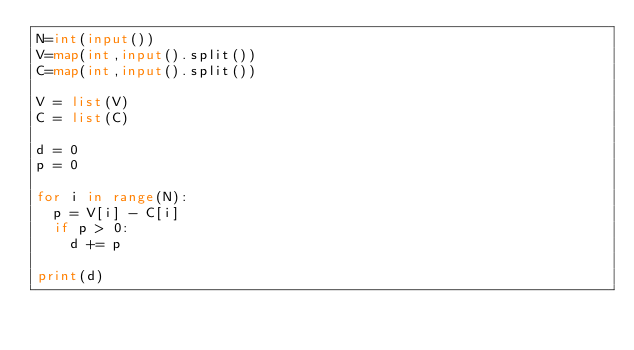Convert code to text. <code><loc_0><loc_0><loc_500><loc_500><_Python_>N=int(input())
V=map(int,input().split())
C=map(int,input().split())

V = list(V)
C = list(C)

d = 0
p = 0

for i in range(N):  
  p = V[i] - C[i]
  if p > 0:
    d += p

print(d)</code> 